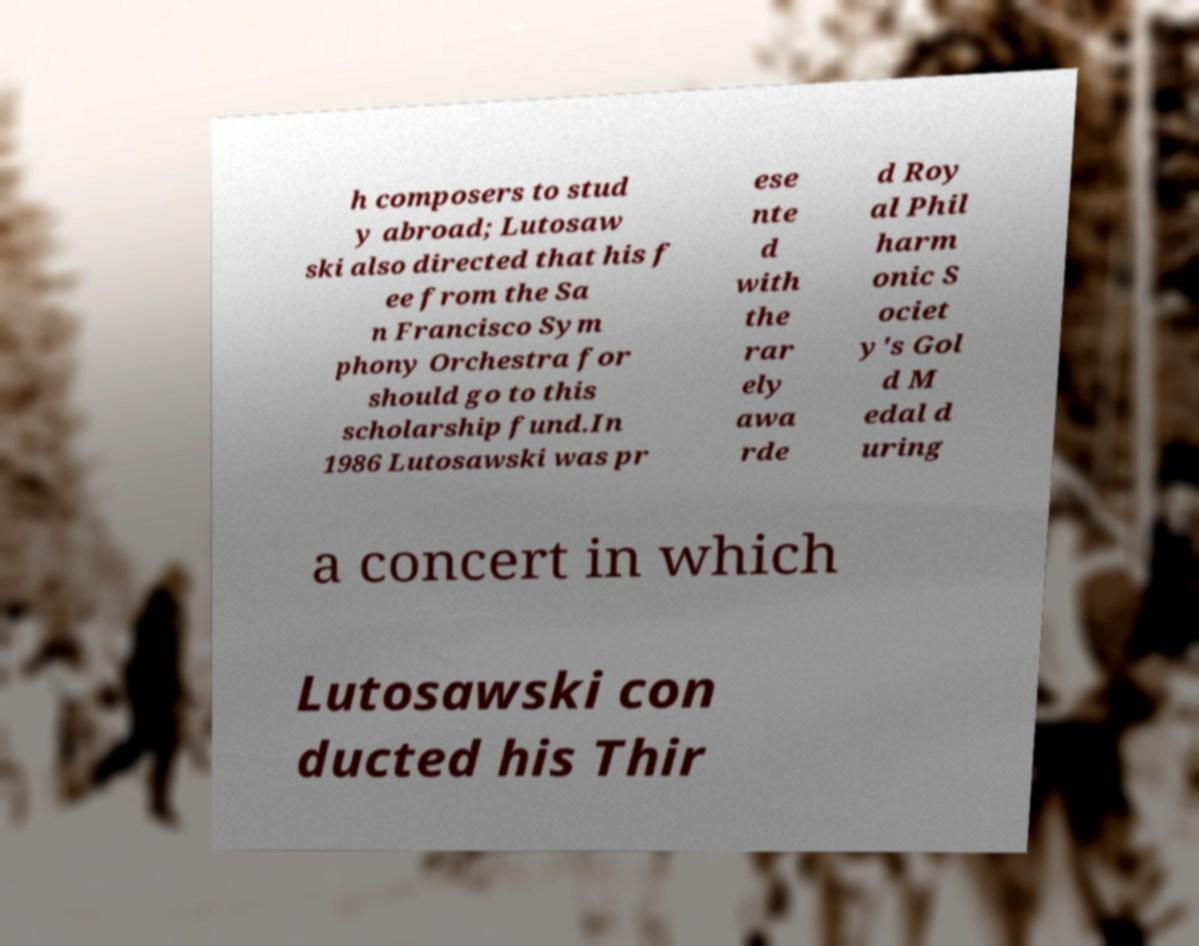Can you accurately transcribe the text from the provided image for me? h composers to stud y abroad; Lutosaw ski also directed that his f ee from the Sa n Francisco Sym phony Orchestra for should go to this scholarship fund.In 1986 Lutosawski was pr ese nte d with the rar ely awa rde d Roy al Phil harm onic S ociet y's Gol d M edal d uring a concert in which Lutosawski con ducted his Thir 